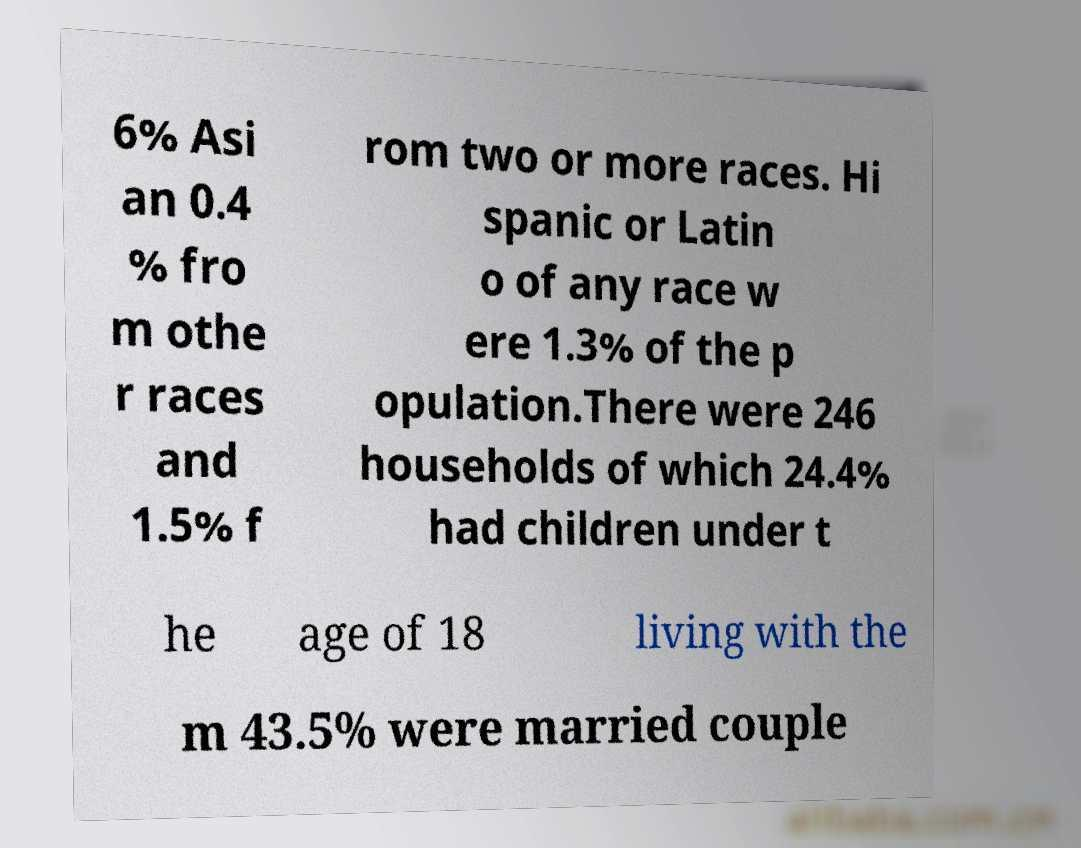There's text embedded in this image that I need extracted. Can you transcribe it verbatim? 6% Asi an 0.4 % fro m othe r races and 1.5% f rom two or more races. Hi spanic or Latin o of any race w ere 1.3% of the p opulation.There were 246 households of which 24.4% had children under t he age of 18 living with the m 43.5% were married couple 